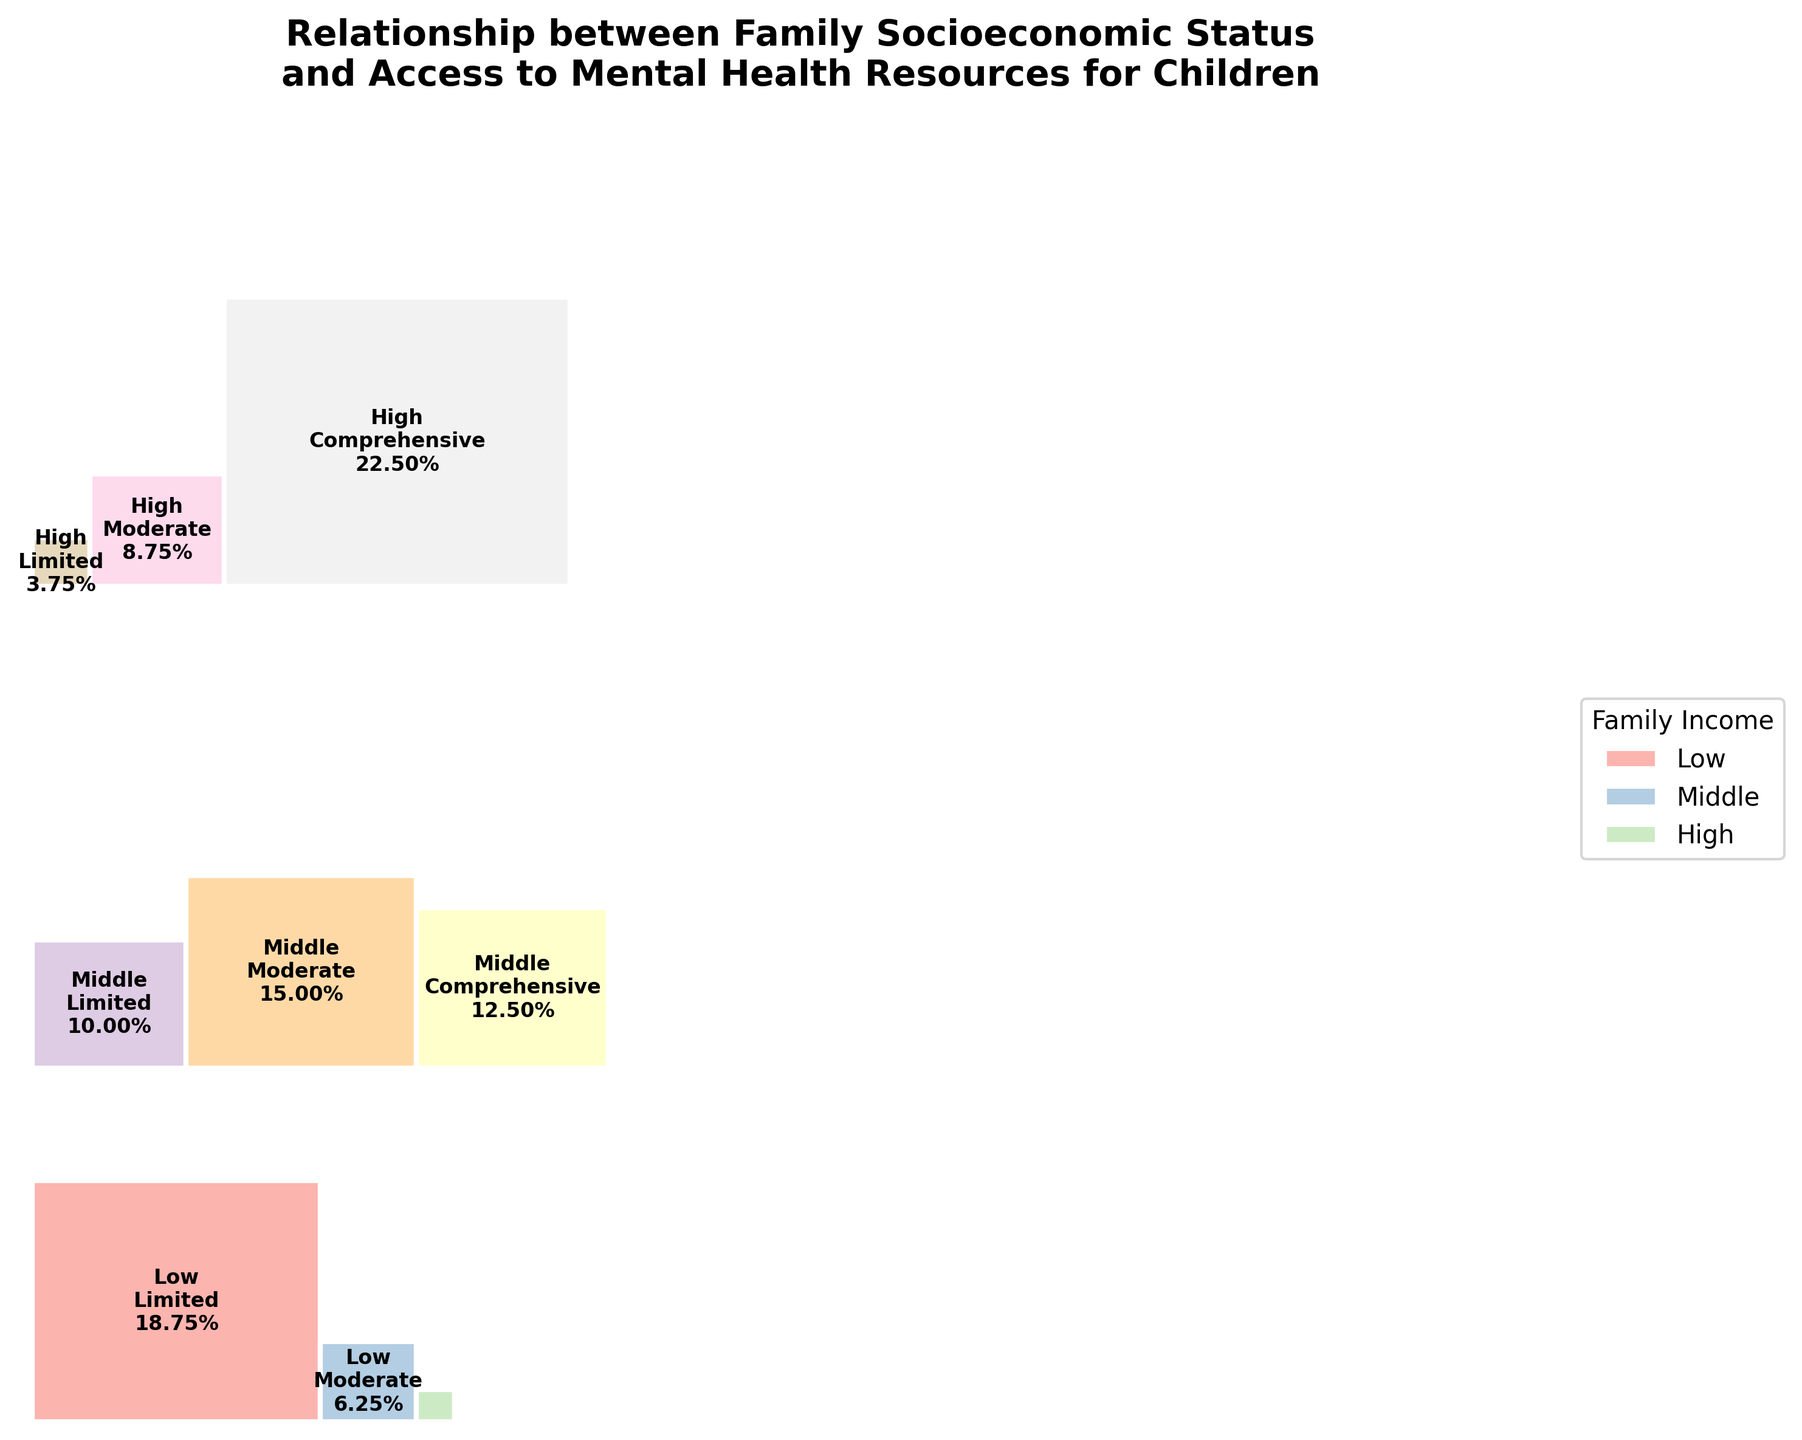What is the title of the figure? The title is located at the top of the plot and is styled in bold and larger font than the other text. It reads, "Relationship between Family Socioeconomic Status and Access to Mental Health Resources for Children"
Answer: Relationship between Family Socioeconomic Status and Access to Mental Health Resources for Children Which family income group has the largest proportion of children with limited mental health access? By visually comparing the proportions within each family income group, we can see that the 'Low' income group has the largest rectangle for 'Limited' mental health access.
Answer: Low What proportion of children from high-income families have comprehensive access to mental health resources? The 'High' income group with 'Comprehensive' access area is represented in the bottom row of the plot. The proportion is labeled within the corresponding rectangle.
Answer: 18.0% How does the proportion of children with moderate mental health access compare between middle and high-income families? We compare the areas labeled 'Moderate' within 'Middle' and 'High' income groups. The label within 'Middle' income shows 12% and 'High' income shows 7%, hence 'Middle' is higher.
Answer: Middle is higher What is the cumulative proportion of children with limited and moderate mental health access from low-income families? We need to sum the proportions of 'Limited' and 'Moderate' within the 'Low' income group. The labels show 15.0% for 'Limited' and 5.0% for 'Moderate'. Thus, the cumulative is 15.0% + 5.0% = 20.0%.
Answer: 20.0% Which family income group has the smallest proportion of children with limited access to mental health resources? By visually comparing the sizes of rectangles labeled 'Limited' across all family income groups, the 'High' income group has the smallest proportion shown by the least rectangle size.
Answer: High What is the difference in proportions of children with comprehensive mental health access between low and high-income families? The proportion of 'Comprehensive' access is labeled within the corresponding rectangles: 2.0% for 'Low' and 18.0% for 'High' income groups. The difference is 18.0% - 2.0% = 16.0%.
Answer: 16.0% What is the combined proportion of children from middle-income families with either moderate or comprehensive access to mental health resources? We add the proportions for 'Middle' income with 'Moderate' and 'Comprehensive' access. The labels show 12% and 10% respectively. Thus, the combined proportion is 12% + 10% = 22%.
Answer: 22% Which combination of family income and mental health access is the least represented? The smallest rectangle in the mosaic plot indicates the least represented group. It is 'Low' income and 'Comprehensive' access with a proportion of 2.0%.
Answer: Low income with Comprehensive access What proportion of children from all families have comprehensive access to mental health resources? We sum the proportions for 'Comprehensive' access across all income groups: 2.0% (Low) + 10.0% (Middle) + 18.0% (High). Therefore, the total proportion is 2.0% + 10.0% + 18.0% = 30.0%.
Answer: 30.0% 